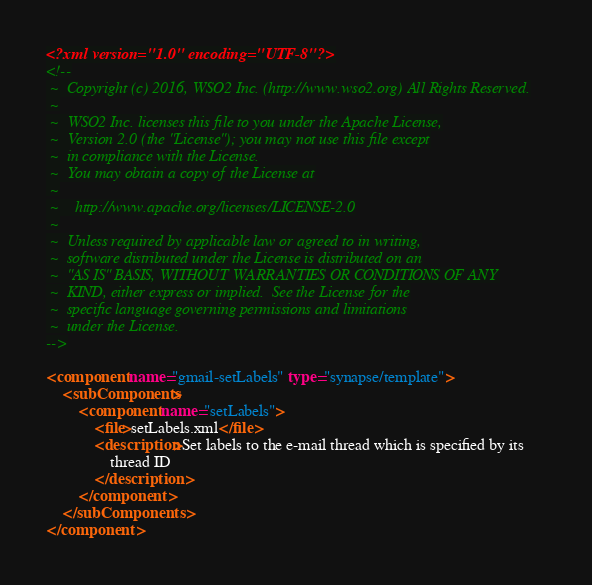Convert code to text. <code><loc_0><loc_0><loc_500><loc_500><_XML_><?xml version="1.0" encoding="UTF-8"?>
<!--
 ~  Copyright (c) 2016, WSO2 Inc. (http://www.wso2.org) All Rights Reserved.
 ~
 ~  WSO2 Inc. licenses this file to you under the Apache License,
 ~  Version 2.0 (the "License"); you may not use this file except
 ~  in compliance with the License.
 ~  You may obtain a copy of the License at
 ~
 ~    http://www.apache.org/licenses/LICENSE-2.0
 ~
 ~  Unless required by applicable law or agreed to in writing,
 ~  software distributed under the License is distributed on an
 ~  "AS IS" BASIS, WITHOUT WARRANTIES OR CONDITIONS OF ANY
 ~  KIND, either express or implied.  See the License for the
 ~  specific language governing permissions and limitations
 ~  under the License.
-->

<component name="gmail-setLabels" type="synapse/template">
    <subComponents>
        <component name="setLabels">
            <file>setLabels.xml</file>
            <description>Set labels to the e-mail thread which is specified by its
                thread ID
            </description>
        </component>
    </subComponents>
</component>
</code> 